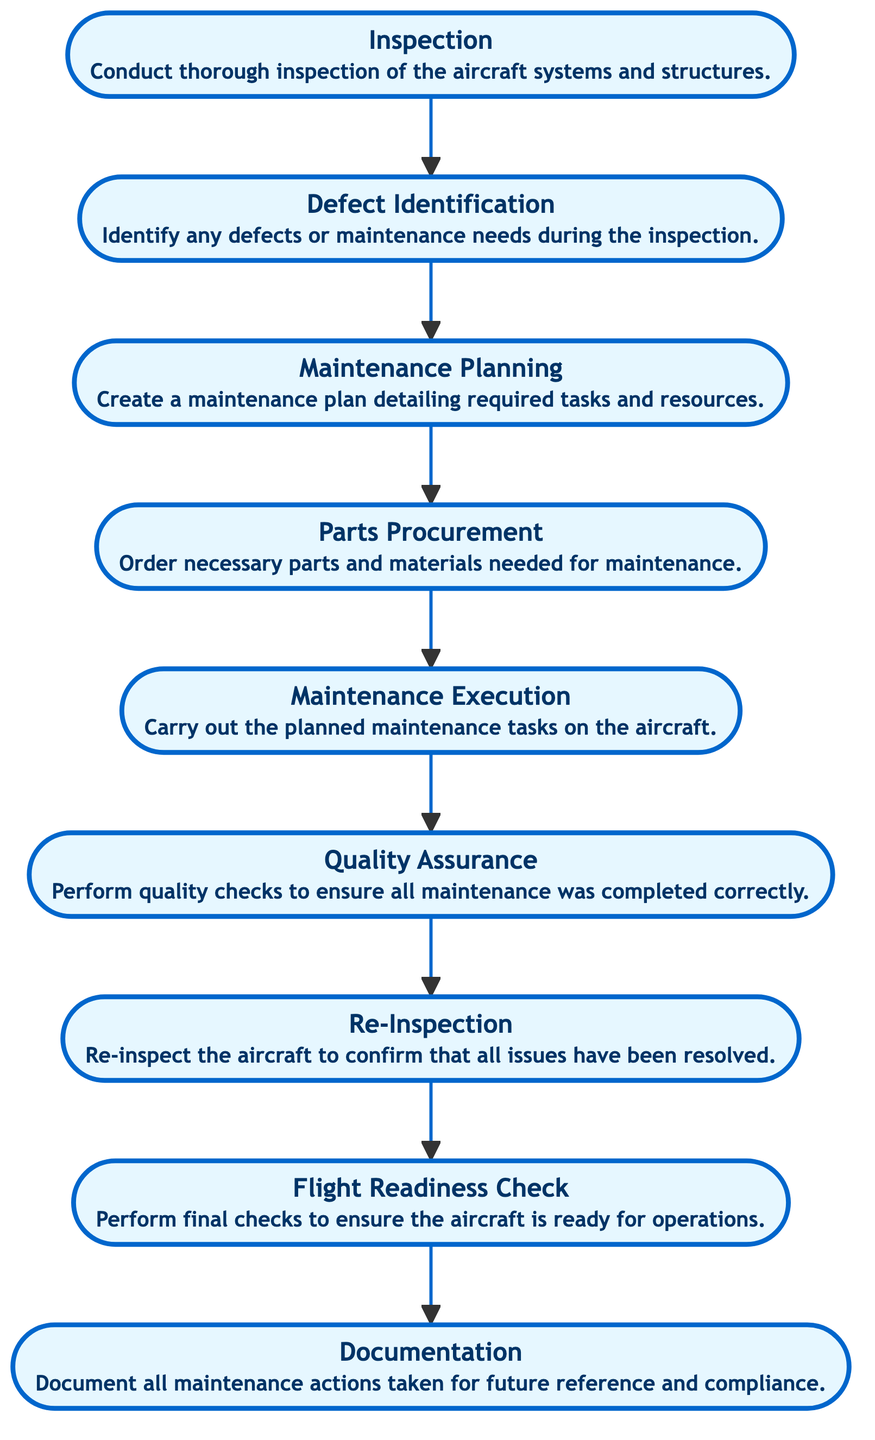What is the first step in the workflow? The diagram starts with the node labeled "Inspection," indicating that the process begins with this step.
Answer: Inspection How many steps are there in total from inspection to documentation? There are eight distinct steps in the flowchart, starting from "Inspection" and ending with "Documentation." By counting the nodes, we arrive at eight.
Answer: Eight Which step directly follows "Maintenance Planning"? The step that comes directly after "Maintenance Planning" is "Parts Procurement," as indicated by the arrow that connects these two nodes in the flowchart.
Answer: Parts Procurement What is the last step in the maintenance workflow? The last step in the workflow is represented by the node labeled "Documentation," which is the final action taken in the process.
Answer: Documentation What is the purpose of the "Quality Assurance" step? The "Quality Assurance" step is meant to perform quality checks to ensure that all maintenance was completed correctly, as stated in its description on the diagram.
Answer: Perform quality checks What is the relationship between "Re-Inspection" and "Flight Readiness Check"? "Re-Inspection" is the step that precedes "Flight Readiness Check," meaning that the aircraft must be re-inspected before confirming its readiness for flight.
Answer: Re-Inspection precedes Flight Readiness Check Which step is focused on acquiring necessary materials? The step involved in acquiring necessary materials is "Parts Procurement," which is explicitly about ordering parts and materials required for maintenance.
Answer: Parts Procurement What document is created after all maintenance actions? The document created after all maintenance actions is called "Documentation," which ensures that all actions taken are recorded for future reference and compliance.
Answer: Documentation What is required before "Maintenance Execution"? Before "Maintenance Execution," there is a need for the "Maintenance Planning" step, where a plan detailing required tasks and resources must be created.
Answer: Maintenance Planning 